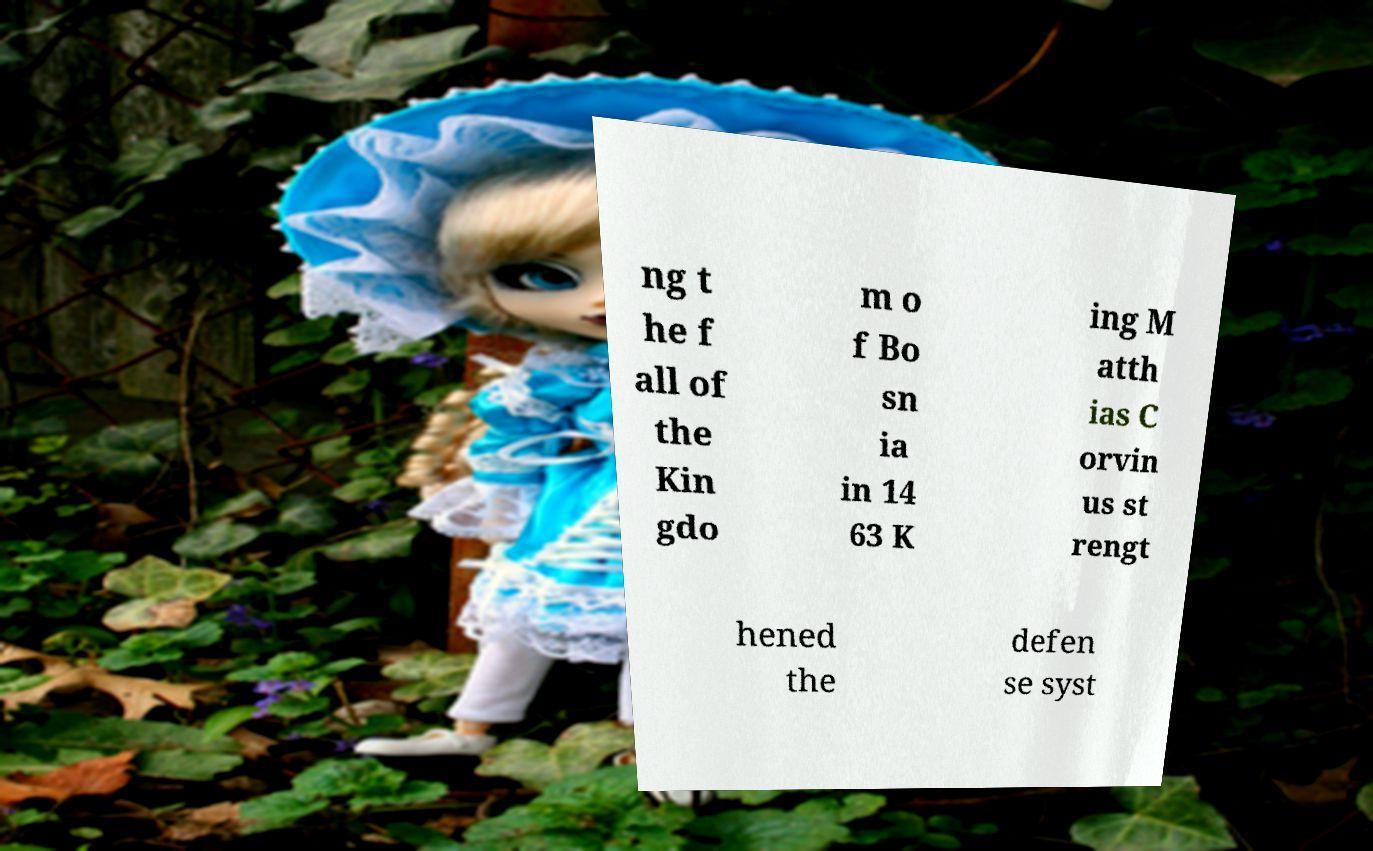What messages or text are displayed in this image? I need them in a readable, typed format. ng t he f all of the Kin gdo m o f Bo sn ia in 14 63 K ing M atth ias C orvin us st rengt hened the defen se syst 